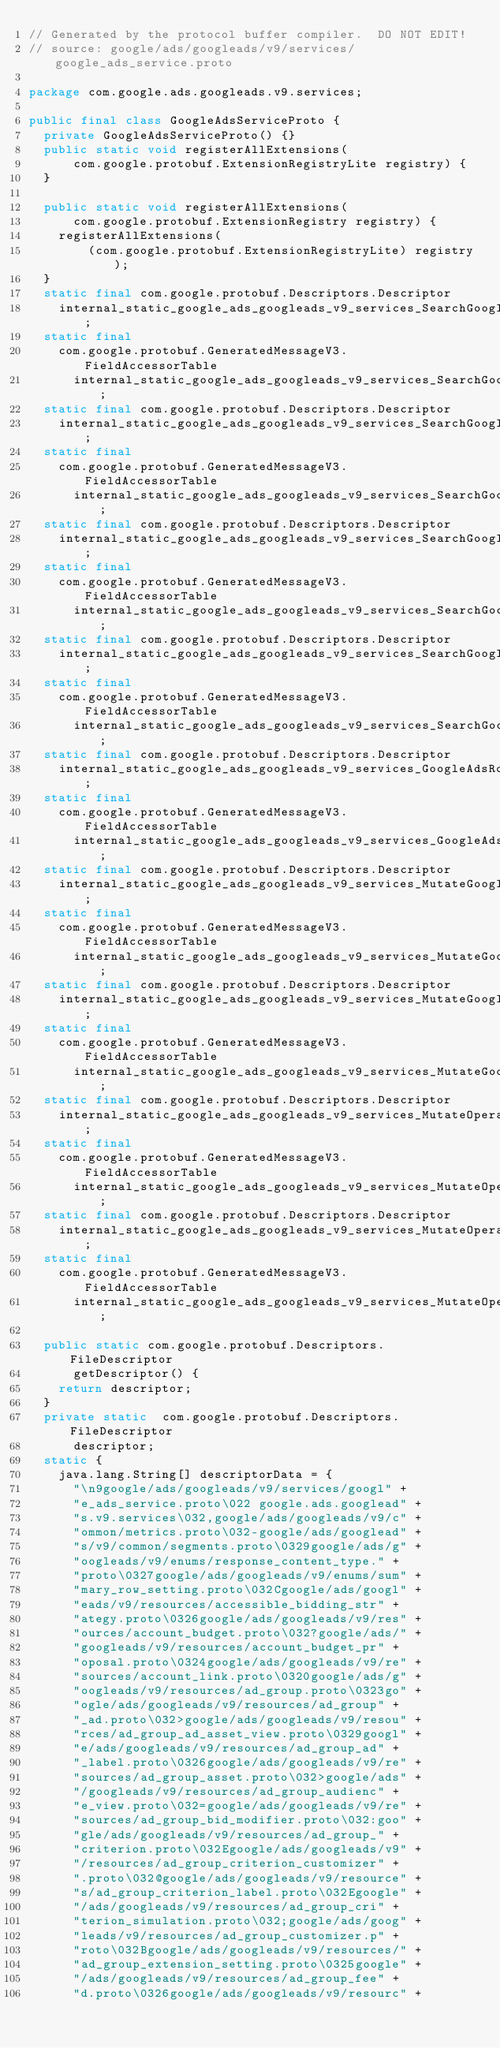<code> <loc_0><loc_0><loc_500><loc_500><_Java_>// Generated by the protocol buffer compiler.  DO NOT EDIT!
// source: google/ads/googleads/v9/services/google_ads_service.proto

package com.google.ads.googleads.v9.services;

public final class GoogleAdsServiceProto {
  private GoogleAdsServiceProto() {}
  public static void registerAllExtensions(
      com.google.protobuf.ExtensionRegistryLite registry) {
  }

  public static void registerAllExtensions(
      com.google.protobuf.ExtensionRegistry registry) {
    registerAllExtensions(
        (com.google.protobuf.ExtensionRegistryLite) registry);
  }
  static final com.google.protobuf.Descriptors.Descriptor
    internal_static_google_ads_googleads_v9_services_SearchGoogleAdsRequest_descriptor;
  static final 
    com.google.protobuf.GeneratedMessageV3.FieldAccessorTable
      internal_static_google_ads_googleads_v9_services_SearchGoogleAdsRequest_fieldAccessorTable;
  static final com.google.protobuf.Descriptors.Descriptor
    internal_static_google_ads_googleads_v9_services_SearchGoogleAdsResponse_descriptor;
  static final 
    com.google.protobuf.GeneratedMessageV3.FieldAccessorTable
      internal_static_google_ads_googleads_v9_services_SearchGoogleAdsResponse_fieldAccessorTable;
  static final com.google.protobuf.Descriptors.Descriptor
    internal_static_google_ads_googleads_v9_services_SearchGoogleAdsStreamRequest_descriptor;
  static final 
    com.google.protobuf.GeneratedMessageV3.FieldAccessorTable
      internal_static_google_ads_googleads_v9_services_SearchGoogleAdsStreamRequest_fieldAccessorTable;
  static final com.google.protobuf.Descriptors.Descriptor
    internal_static_google_ads_googleads_v9_services_SearchGoogleAdsStreamResponse_descriptor;
  static final 
    com.google.protobuf.GeneratedMessageV3.FieldAccessorTable
      internal_static_google_ads_googleads_v9_services_SearchGoogleAdsStreamResponse_fieldAccessorTable;
  static final com.google.protobuf.Descriptors.Descriptor
    internal_static_google_ads_googleads_v9_services_GoogleAdsRow_descriptor;
  static final 
    com.google.protobuf.GeneratedMessageV3.FieldAccessorTable
      internal_static_google_ads_googleads_v9_services_GoogleAdsRow_fieldAccessorTable;
  static final com.google.protobuf.Descriptors.Descriptor
    internal_static_google_ads_googleads_v9_services_MutateGoogleAdsRequest_descriptor;
  static final 
    com.google.protobuf.GeneratedMessageV3.FieldAccessorTable
      internal_static_google_ads_googleads_v9_services_MutateGoogleAdsRequest_fieldAccessorTable;
  static final com.google.protobuf.Descriptors.Descriptor
    internal_static_google_ads_googleads_v9_services_MutateGoogleAdsResponse_descriptor;
  static final 
    com.google.protobuf.GeneratedMessageV3.FieldAccessorTable
      internal_static_google_ads_googleads_v9_services_MutateGoogleAdsResponse_fieldAccessorTable;
  static final com.google.protobuf.Descriptors.Descriptor
    internal_static_google_ads_googleads_v9_services_MutateOperation_descriptor;
  static final 
    com.google.protobuf.GeneratedMessageV3.FieldAccessorTable
      internal_static_google_ads_googleads_v9_services_MutateOperation_fieldAccessorTable;
  static final com.google.protobuf.Descriptors.Descriptor
    internal_static_google_ads_googleads_v9_services_MutateOperationResponse_descriptor;
  static final 
    com.google.protobuf.GeneratedMessageV3.FieldAccessorTable
      internal_static_google_ads_googleads_v9_services_MutateOperationResponse_fieldAccessorTable;

  public static com.google.protobuf.Descriptors.FileDescriptor
      getDescriptor() {
    return descriptor;
  }
  private static  com.google.protobuf.Descriptors.FileDescriptor
      descriptor;
  static {
    java.lang.String[] descriptorData = {
      "\n9google/ads/googleads/v9/services/googl" +
      "e_ads_service.proto\022 google.ads.googlead" +
      "s.v9.services\032,google/ads/googleads/v9/c" +
      "ommon/metrics.proto\032-google/ads/googlead" +
      "s/v9/common/segments.proto\0329google/ads/g" +
      "oogleads/v9/enums/response_content_type." +
      "proto\0327google/ads/googleads/v9/enums/sum" +
      "mary_row_setting.proto\032Cgoogle/ads/googl" +
      "eads/v9/resources/accessible_bidding_str" +
      "ategy.proto\0326google/ads/googleads/v9/res" +
      "ources/account_budget.proto\032?google/ads/" +
      "googleads/v9/resources/account_budget_pr" +
      "oposal.proto\0324google/ads/googleads/v9/re" +
      "sources/account_link.proto\0320google/ads/g" +
      "oogleads/v9/resources/ad_group.proto\0323go" +
      "ogle/ads/googleads/v9/resources/ad_group" +
      "_ad.proto\032>google/ads/googleads/v9/resou" +
      "rces/ad_group_ad_asset_view.proto\0329googl" +
      "e/ads/googleads/v9/resources/ad_group_ad" +
      "_label.proto\0326google/ads/googleads/v9/re" +
      "sources/ad_group_asset.proto\032>google/ads" +
      "/googleads/v9/resources/ad_group_audienc" +
      "e_view.proto\032=google/ads/googleads/v9/re" +
      "sources/ad_group_bid_modifier.proto\032:goo" +
      "gle/ads/googleads/v9/resources/ad_group_" +
      "criterion.proto\032Egoogle/ads/googleads/v9" +
      "/resources/ad_group_criterion_customizer" +
      ".proto\032@google/ads/googleads/v9/resource" +
      "s/ad_group_criterion_label.proto\032Egoogle" +
      "/ads/googleads/v9/resources/ad_group_cri" +
      "terion_simulation.proto\032;google/ads/goog" +
      "leads/v9/resources/ad_group_customizer.p" +
      "roto\032Bgoogle/ads/googleads/v9/resources/" +
      "ad_group_extension_setting.proto\0325google" +
      "/ads/googleads/v9/resources/ad_group_fee" +
      "d.proto\0326google/ads/googleads/v9/resourc" +</code> 